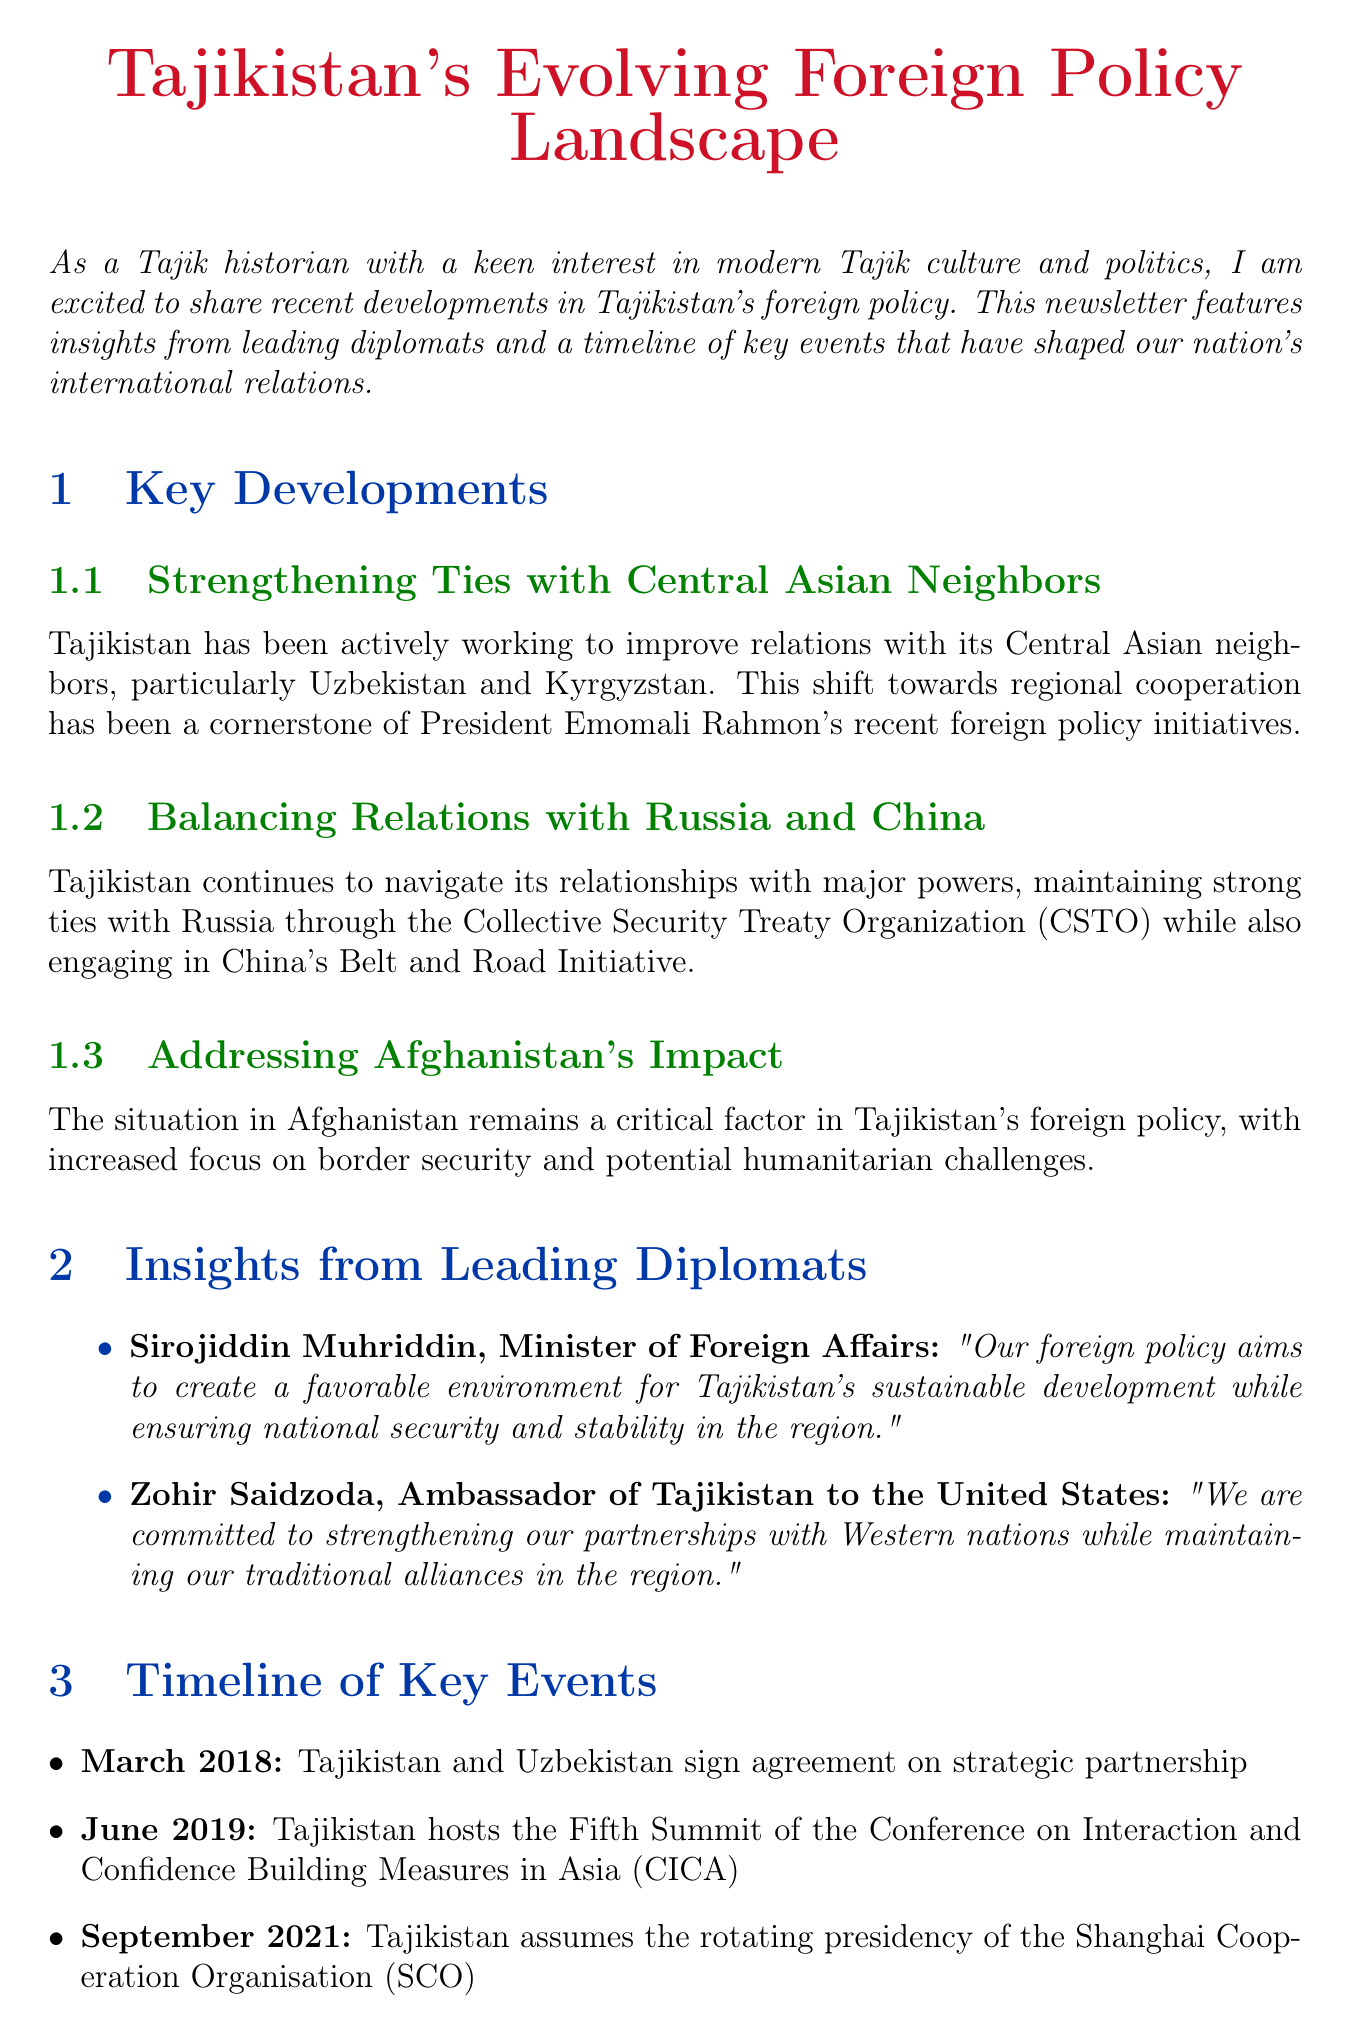What is the title of the newsletter? The title of the newsletter is explicitly stated at the beginning of the document.
Answer: Tajikistan's Evolving Foreign Policy Landscape Who is the Minister of Foreign Affairs? The document provides the name and position of key diplomats, including the Minister of Foreign Affairs.
Answer: Sirojiddin Muhriddin What event did Tajikistan host in June 2019? The timeline section lists key events and their dates, including the event hosted by Tajikistan.
Answer: Fifth Summit of the Conference on Interaction and Confidence Building Measures in Asia (CICA) What is a key factor in Tajikistan's foreign policy? The document highlights critical themes, including security concerns related to Afghanistan.
Answer: Afghanistan's Impact When did Tajikistan sign an agreement on strategic partnership with Uzbekistan? The timeline provides specific dates for significant agreements and events in Tajikistan's foreign relations.
Answer: March 2018 What does Tajikistan aim to create through its foreign policy? The insights from diplomats articulate the objectives of Tajikistan's foreign policy.
Answer: Favorable environment for sustainable development Which major powers is Tajikistan balancing relations with? The document specifically mentions the major powers involved in Tajikistan's foreign policy.
Answer: Russia and China What does the analysis section reflect regarding Tajikistan's foreign policy? The analysis section summarizes the document's overall assessment of Tajikistan's foreign policy efforts.
Answer: Diversify its foreign relations What cultural perspective is mentioned in the newsletter? The cultural perspective section discusses the historical context of Tajikistan's foreign policy.
Answer: Rich cultural heritage and historical ties to the Silk Road 